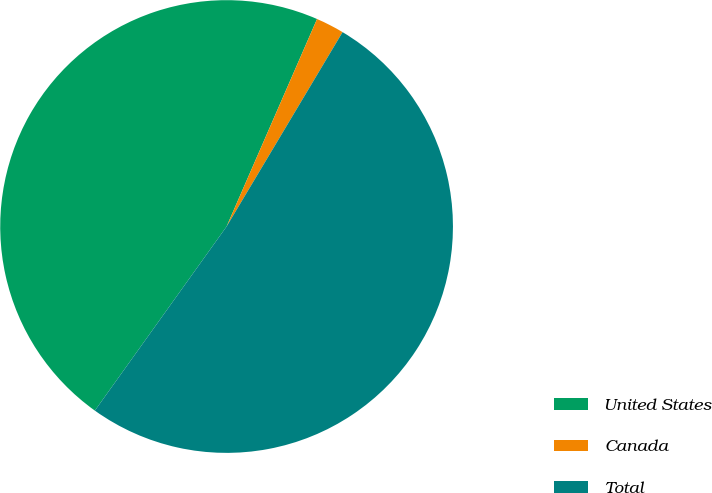Convert chart. <chart><loc_0><loc_0><loc_500><loc_500><pie_chart><fcel>United States<fcel>Canada<fcel>Total<nl><fcel>46.66%<fcel>2.02%<fcel>51.32%<nl></chart> 